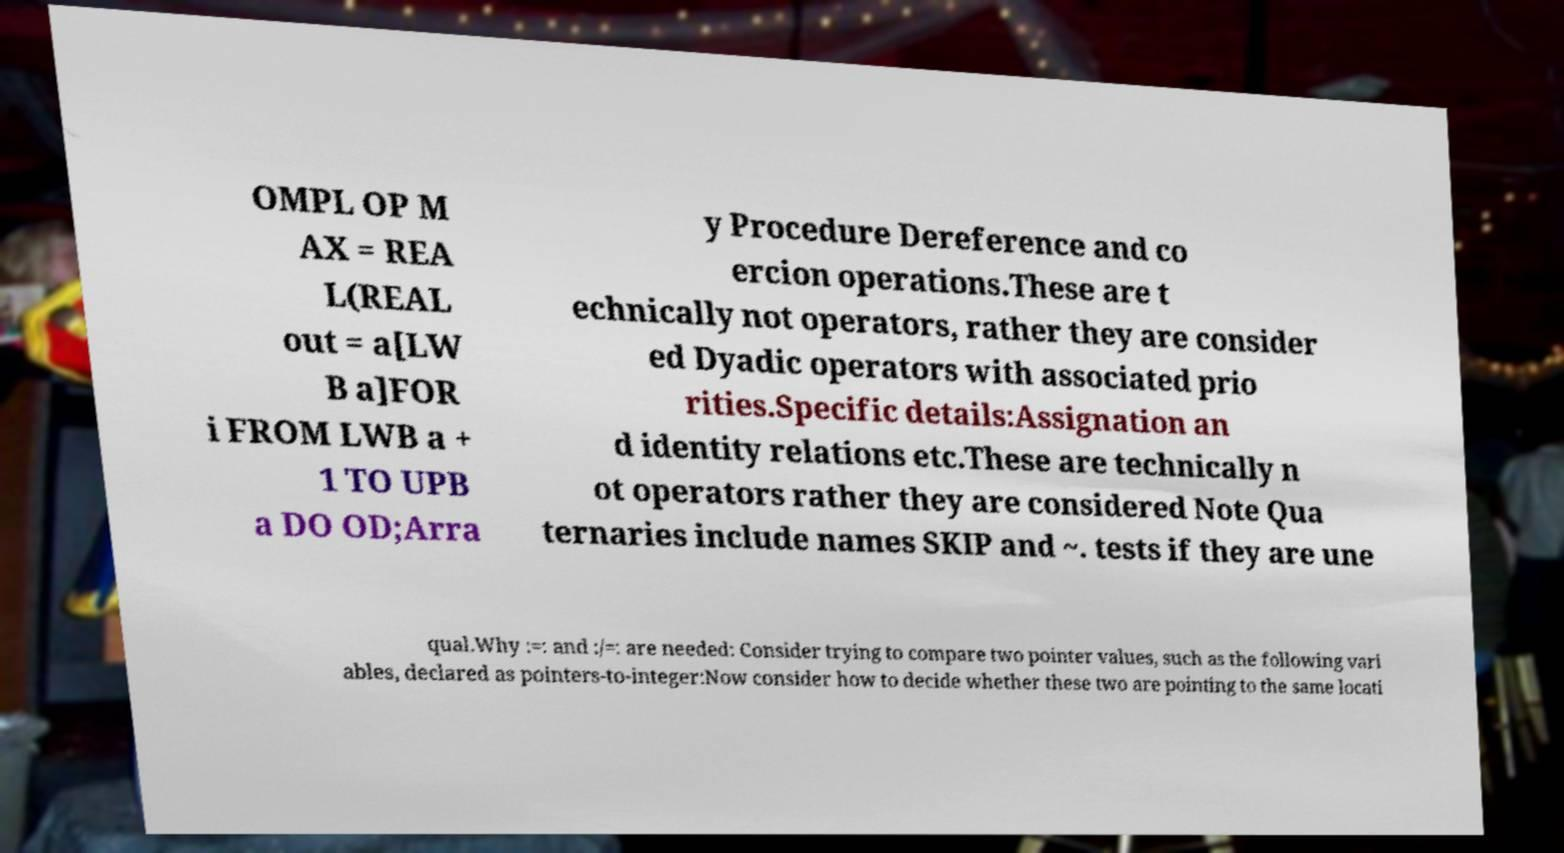There's text embedded in this image that I need extracted. Can you transcribe it verbatim? OMPL OP M AX = REA L(REAL out = a[LW B a]FOR i FROM LWB a + 1 TO UPB a DO OD;Arra y Procedure Dereference and co ercion operations.These are t echnically not operators, rather they are consider ed Dyadic operators with associated prio rities.Specific details:Assignation an d identity relations etc.These are technically n ot operators rather they are considered Note Qua ternaries include names SKIP and ~. tests if they are une qual.Why :=: and :/=: are needed: Consider trying to compare two pointer values, such as the following vari ables, declared as pointers-to-integer:Now consider how to decide whether these two are pointing to the same locati 